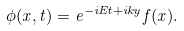<formula> <loc_0><loc_0><loc_500><loc_500>\phi ( { x } , t ) = e ^ { - i E t + i k y } f ( x ) .</formula> 